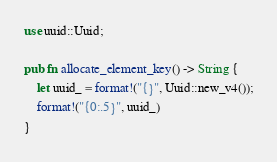Convert code to text. <code><loc_0><loc_0><loc_500><loc_500><_Rust_>use uuid::Uuid;

pub fn allocate_element_key() -> String {
    let uuid_ = format!("{}", Uuid::new_v4());
    format!("{0:.5}", uuid_)
}
</code> 